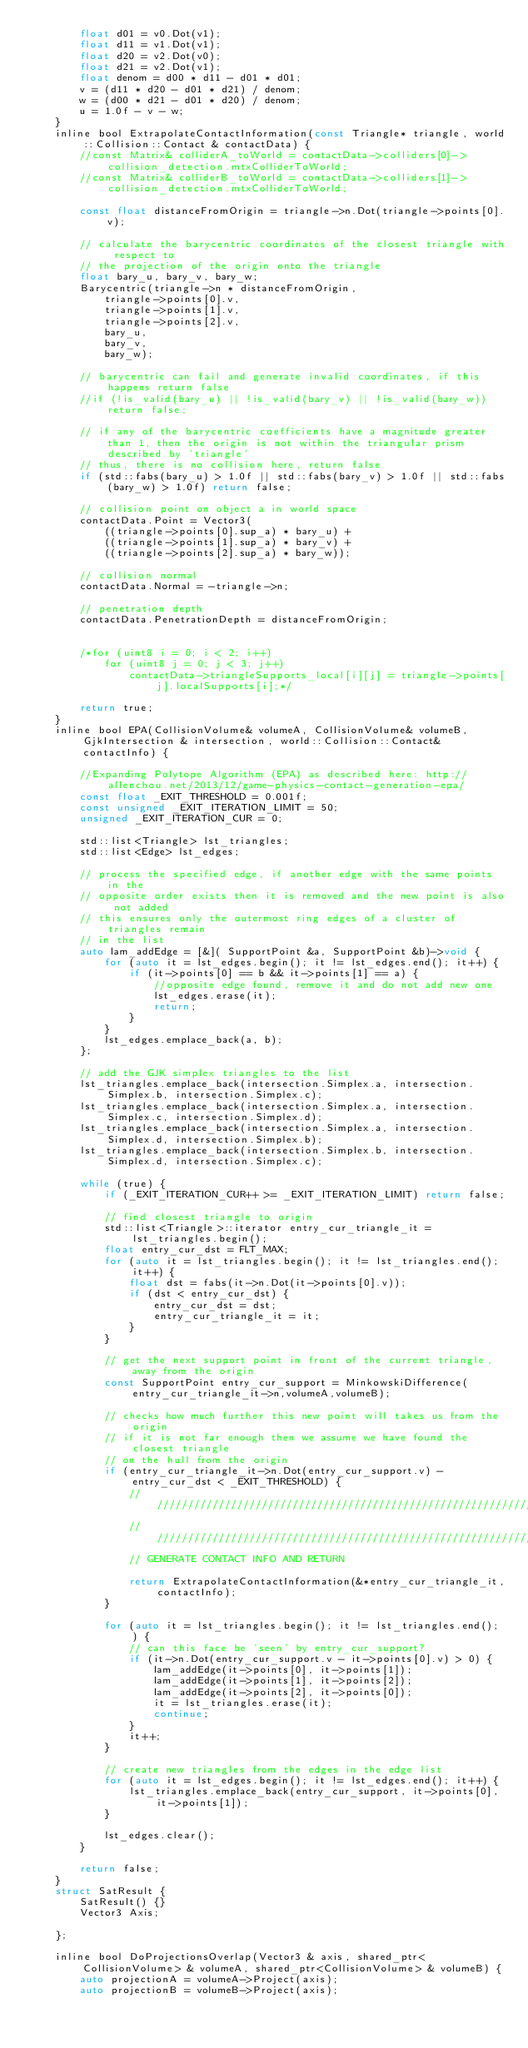<code> <loc_0><loc_0><loc_500><loc_500><_C_>		float d01 = v0.Dot(v1);
		float d11 = v1.Dot(v1);
		float d20 = v2.Dot(v0);
		float d21 = v2.Dot(v1);
		float denom = d00 * d11 - d01 * d01;
		v = (d11 * d20 - d01 * d21) / denom;
		w = (d00 * d21 - d01 * d20) / denom;
		u = 1.0f - v - w;
	}
	inline bool ExtrapolateContactInformation(const Triangle* triangle, world::Collision::Contact & contactData) {
		//const Matrix& colliderA_toWorld = contactData->colliders[0]->collision_detection.mtxColliderToWorld;
		//const Matrix& colliderB_toWorld = contactData->colliders[1]->collision_detection.mtxColliderToWorld;

		const float distanceFromOrigin = triangle->n.Dot(triangle->points[0].v);

		// calculate the barycentric coordinates of the closest triangle with respect to
		// the projection of the origin onto the triangle
		float bary_u, bary_v, bary_w;
		Barycentric(triangle->n * distanceFromOrigin,
			triangle->points[0].v,
			triangle->points[1].v,
			triangle->points[2].v,
			bary_u,
			bary_v,
			bary_w);

		// barycentric can fail and generate invalid coordinates, if this happens return false
		//if (!is_valid(bary_u) || !is_valid(bary_v) || !is_valid(bary_w)) return false;

		// if any of the barycentric coefficients have a magnitude greater than 1, then the origin is not within the triangular prism described by 'triangle'
		// thus, there is no collision here, return false
		if (std::fabs(bary_u) > 1.0f || std::fabs(bary_v) > 1.0f || std::fabs(bary_w) > 1.0f) return false;

		// collision point on object a in world space
		contactData.Point = Vector3(
			((triangle->points[0].sup_a) * bary_u) +
			((triangle->points[1].sup_a) * bary_v) +
			((triangle->points[2].sup_a) * bary_w));

		// collision normal
		contactData.Normal = -triangle->n;

		// penetration depth
		contactData.PenetrationDepth = distanceFromOrigin;


		/*for (uint8 i = 0; i < 2; i++)
			for (uint8 j = 0; j < 3; j++)
				contactData->triangleSupports_local[i][j] = triangle->points[j].localSupports[i];*/

		return true;
	}
	inline bool EPA(CollisionVolume& volumeA, CollisionVolume& volumeB, GjkIntersection & intersection, world::Collision::Contact& contactInfo) {
		
		//Expanding Polytope Algorithm (EPA) as described here: http://allenchou.net/2013/12/game-physics-contact-generation-epa/
		const float _EXIT_THRESHOLD = 0.001f;
		const unsigned _EXIT_ITERATION_LIMIT = 50;
		unsigned _EXIT_ITERATION_CUR = 0;

		std::list<Triangle> lst_triangles;
		std::list<Edge> lst_edges;

		// process the specified edge, if another edge with the same points in the
		// opposite order exists then it is removed and the new point is also not added
		// this ensures only the outermost ring edges of a cluster of triangles remain
		// in the list
		auto lam_addEdge = [&]( SupportPoint &a, SupportPoint &b)->void {
			for (auto it = lst_edges.begin(); it != lst_edges.end(); it++) {
				if (it->points[0] == b && it->points[1] == a) {
					//opposite edge found, remove it and do not add new one
					lst_edges.erase(it);
					return;
				}
			}
			lst_edges.emplace_back(a, b);
		};

		// add the GJK simplex triangles to the list
		lst_triangles.emplace_back(intersection.Simplex.a, intersection.Simplex.b, intersection.Simplex.c);
		lst_triangles.emplace_back(intersection.Simplex.a, intersection.Simplex.c, intersection.Simplex.d);
		lst_triangles.emplace_back(intersection.Simplex.a, intersection.Simplex.d, intersection.Simplex.b);
		lst_triangles.emplace_back(intersection.Simplex.b, intersection.Simplex.d, intersection.Simplex.c);

		while (true) {
			if (_EXIT_ITERATION_CUR++ >= _EXIT_ITERATION_LIMIT) return false;

			// find closest triangle to origin
			std::list<Triangle>::iterator entry_cur_triangle_it = lst_triangles.begin();
			float entry_cur_dst = FLT_MAX;
			for (auto it = lst_triangles.begin(); it != lst_triangles.end(); it++) {
				float dst = fabs(it->n.Dot(it->points[0].v));
				if (dst < entry_cur_dst) {
					entry_cur_dst = dst;
					entry_cur_triangle_it = it;
				}
			}

			// get the next support point in front of the current triangle, away from the origin
			const SupportPoint entry_cur_support = MinkowskiDifference(entry_cur_triangle_it->n,volumeA,volumeB);

			// checks how much further this new point will takes us from the origin
			// if it is not far enough then we assume we have found the closest triangle
			// on the hull from the origin
			if (entry_cur_triangle_it->n.Dot(entry_cur_support.v) - entry_cur_dst < _EXIT_THRESHOLD) {
				//////////////////////////////////////////////////////////////////////////
				//////////////////////////////////////////////////////////////////////////
				// GENERATE CONTACT INFO AND RETURN

				return ExtrapolateContactInformation(&*entry_cur_triangle_it,contactInfo);
			}

			for (auto it = lst_triangles.begin(); it != lst_triangles.end(); ) {
				// can this face be 'seen' by entry_cur_support?
				if (it->n.Dot(entry_cur_support.v - it->points[0].v) > 0) {
					lam_addEdge(it->points[0], it->points[1]);
					lam_addEdge(it->points[1], it->points[2]);
					lam_addEdge(it->points[2], it->points[0]);
					it = lst_triangles.erase(it);
					continue;
				}
				it++;
			}

			// create new triangles from the edges in the edge list
			for (auto it = lst_edges.begin(); it != lst_edges.end(); it++) {
				lst_triangles.emplace_back(entry_cur_support, it->points[0], it->points[1]);
			}

			lst_edges.clear();
		}

		return false;
	}
	struct SatResult {
		SatResult() {}
		Vector3 Axis;

	};
	
	inline bool DoProjectionsOverlap(Vector3 & axis, shared_ptr<CollisionVolume> & volumeA, shared_ptr<CollisionVolume> & volumeB) {
		auto projectionA = volumeA->Project(axis);
		auto projectionB = volumeB->Project(axis);</code> 